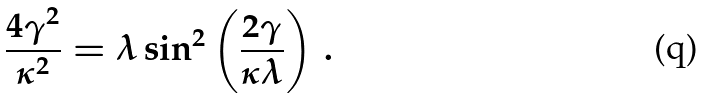<formula> <loc_0><loc_0><loc_500><loc_500>\frac { 4 \gamma ^ { 2 } } { \kappa ^ { 2 } } = \lambda \sin ^ { 2 } \left ( \frac { 2 \gamma } { \kappa \lambda } \right ) \, .</formula> 